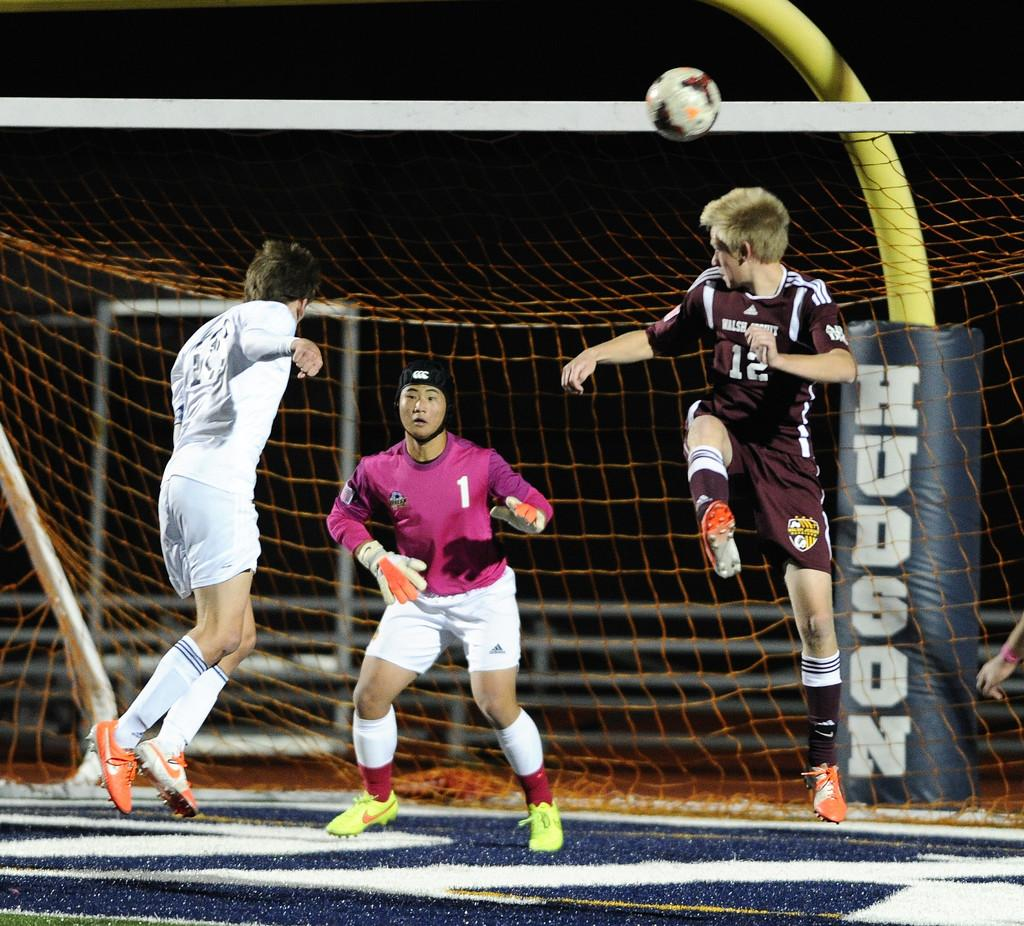<image>
Provide a brief description of the given image. A soccer player with the number 12 on his jersey leaps into the air towards the goalie. 